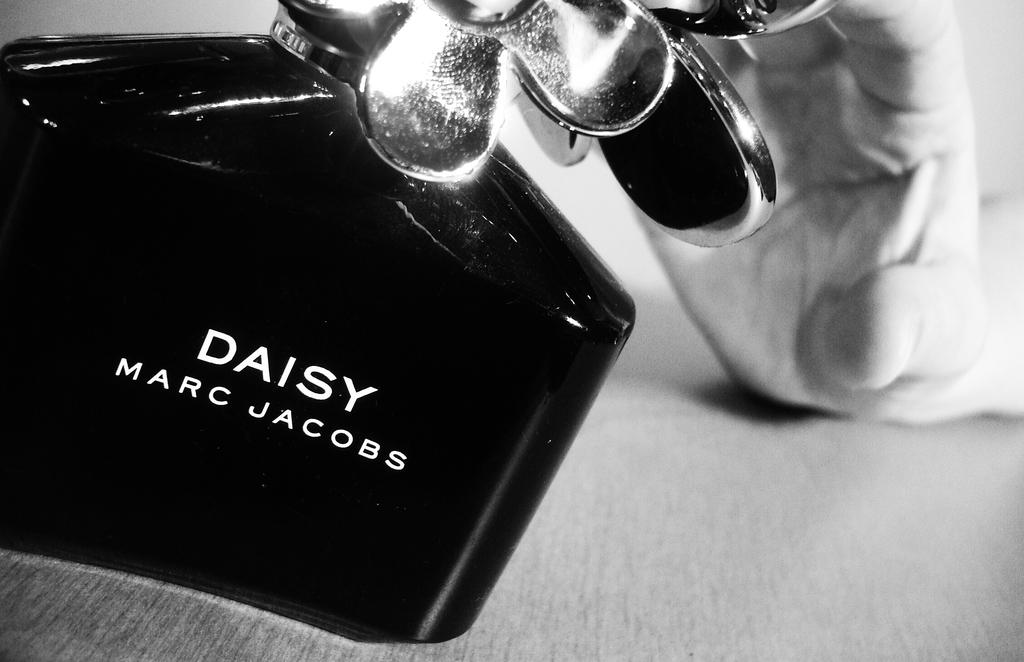<image>
Give a short and clear explanation of the subsequent image. Person holding a bottle of Daisy by Marc Jacobs. 